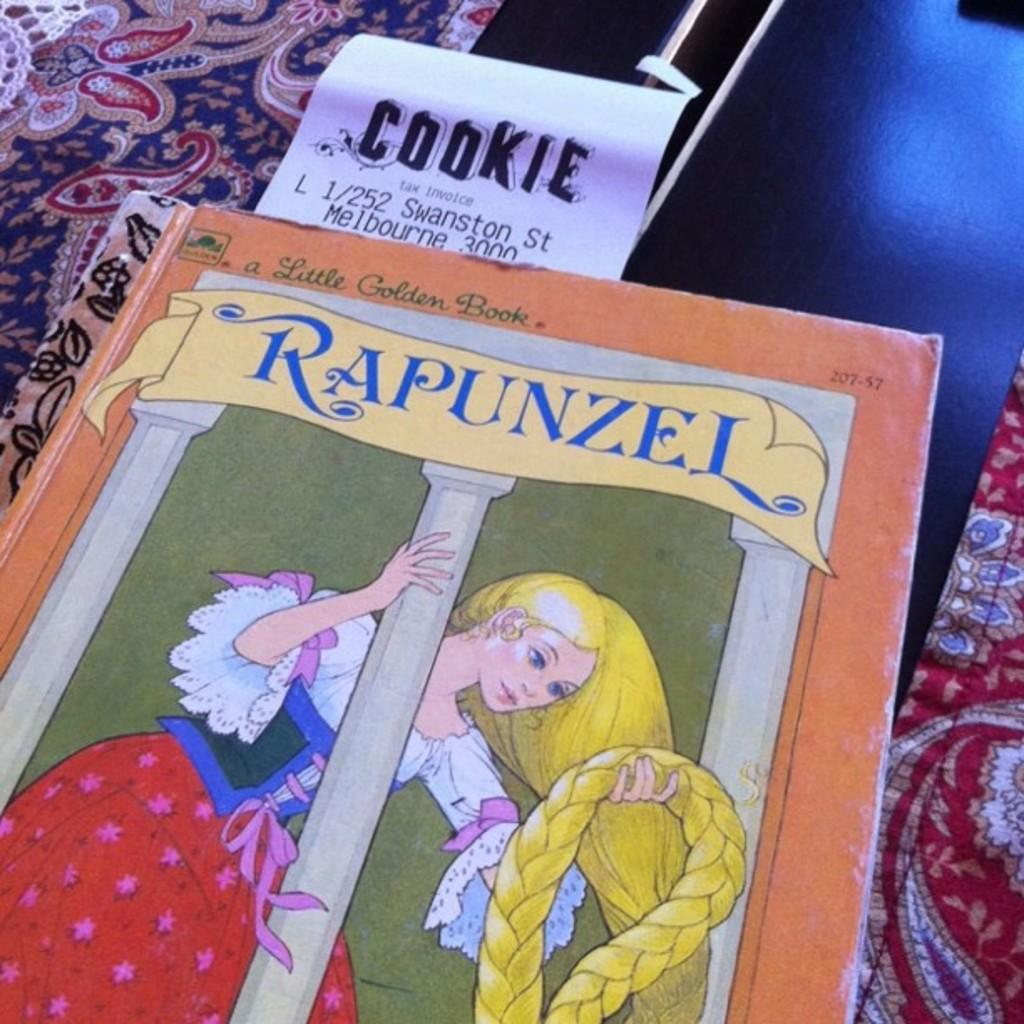Provide a one-sentence caption for the provided image. A Little Golden Book titled Rapunzel with a receipt that states Cookie. 